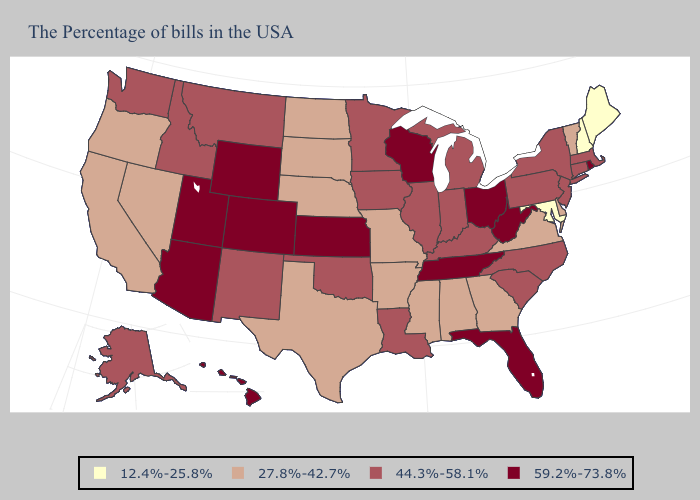What is the value of South Carolina?
Keep it brief. 44.3%-58.1%. Does North Carolina have the highest value in the USA?
Keep it brief. No. Which states have the lowest value in the USA?
Answer briefly. Maine, New Hampshire, Maryland. Name the states that have a value in the range 59.2%-73.8%?
Write a very short answer. Rhode Island, West Virginia, Ohio, Florida, Tennessee, Wisconsin, Kansas, Wyoming, Colorado, Utah, Arizona, Hawaii. Does Hawaii have a lower value than Montana?
Answer briefly. No. What is the value of Idaho?
Answer briefly. 44.3%-58.1%. What is the value of Tennessee?
Short answer required. 59.2%-73.8%. Name the states that have a value in the range 12.4%-25.8%?
Give a very brief answer. Maine, New Hampshire, Maryland. What is the value of Nevada?
Be succinct. 27.8%-42.7%. What is the highest value in the USA?
Keep it brief. 59.2%-73.8%. What is the highest value in the Northeast ?
Be succinct. 59.2%-73.8%. Does Oregon have a lower value than New York?
Give a very brief answer. Yes. What is the lowest value in the USA?
Concise answer only. 12.4%-25.8%. Does Ohio have the highest value in the MidWest?
Give a very brief answer. Yes. Name the states that have a value in the range 44.3%-58.1%?
Short answer required. Massachusetts, Connecticut, New York, New Jersey, Pennsylvania, North Carolina, South Carolina, Michigan, Kentucky, Indiana, Illinois, Louisiana, Minnesota, Iowa, Oklahoma, New Mexico, Montana, Idaho, Washington, Alaska. 